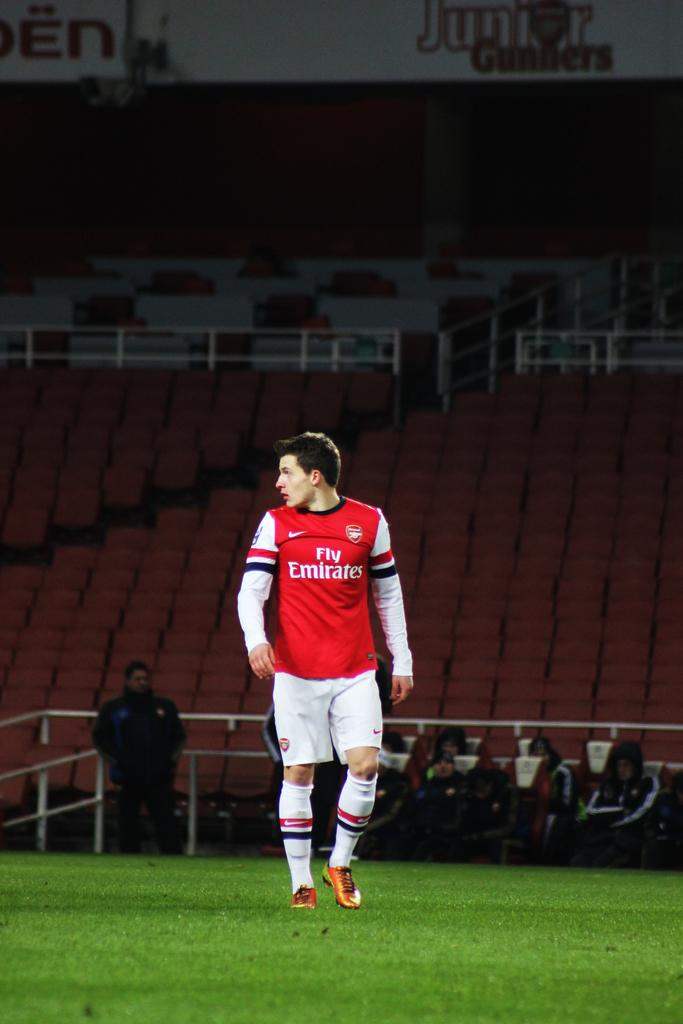Provide a one-sentence caption for the provided image. Man wearing a red and white jersey that says Fly Emirates. 